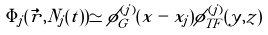Convert formula to latex. <formula><loc_0><loc_0><loc_500><loc_500>\Phi _ { j } ( \vec { r } , N _ { j } ( t ) ) \simeq \phi _ { G } ^ { ( j ) } ( x - x _ { j } ) \phi _ { T F } ^ { ( j ) } ( y , z )</formula> 